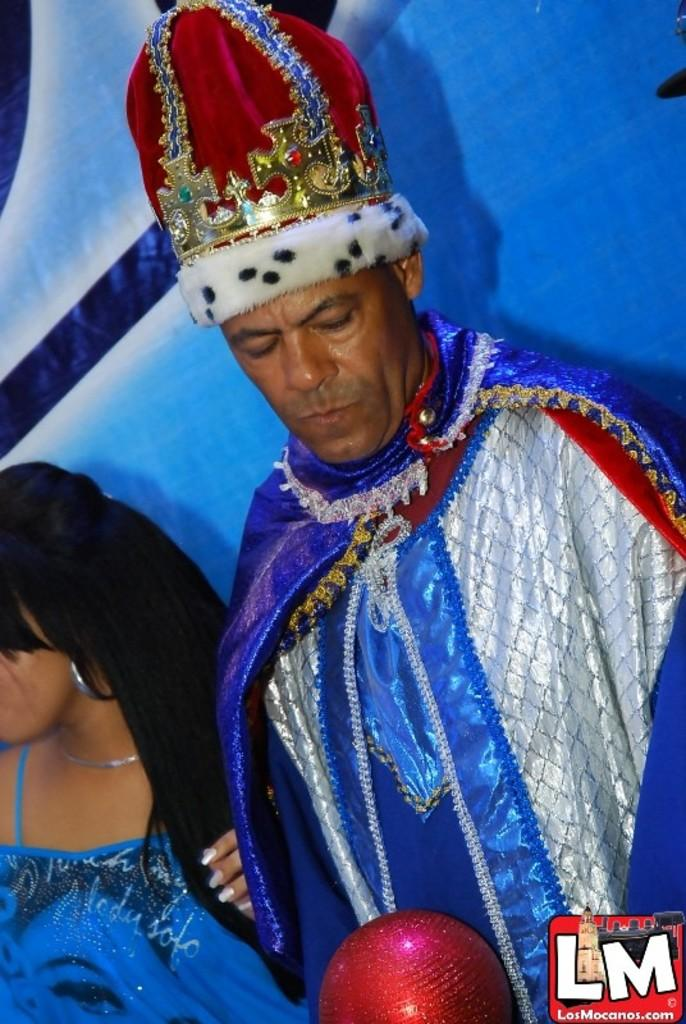Who is present in the image? There is a person and a lady in the image. What are the person and lady doing in the image? The person and lady are standing. What can be seen in the background of the image? There is a banner in the background of the image. What type of suit is the person wearing in the image? There is no suit visible in the image; the person and lady are not wearing any clothing mentioned in the facts. 